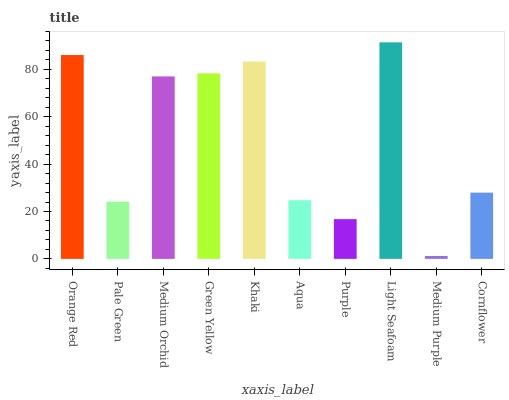Is Medium Purple the minimum?
Answer yes or no. Yes. Is Light Seafoam the maximum?
Answer yes or no. Yes. Is Pale Green the minimum?
Answer yes or no. No. Is Pale Green the maximum?
Answer yes or no. No. Is Orange Red greater than Pale Green?
Answer yes or no. Yes. Is Pale Green less than Orange Red?
Answer yes or no. Yes. Is Pale Green greater than Orange Red?
Answer yes or no. No. Is Orange Red less than Pale Green?
Answer yes or no. No. Is Medium Orchid the high median?
Answer yes or no. Yes. Is Cornflower the low median?
Answer yes or no. Yes. Is Orange Red the high median?
Answer yes or no. No. Is Purple the low median?
Answer yes or no. No. 